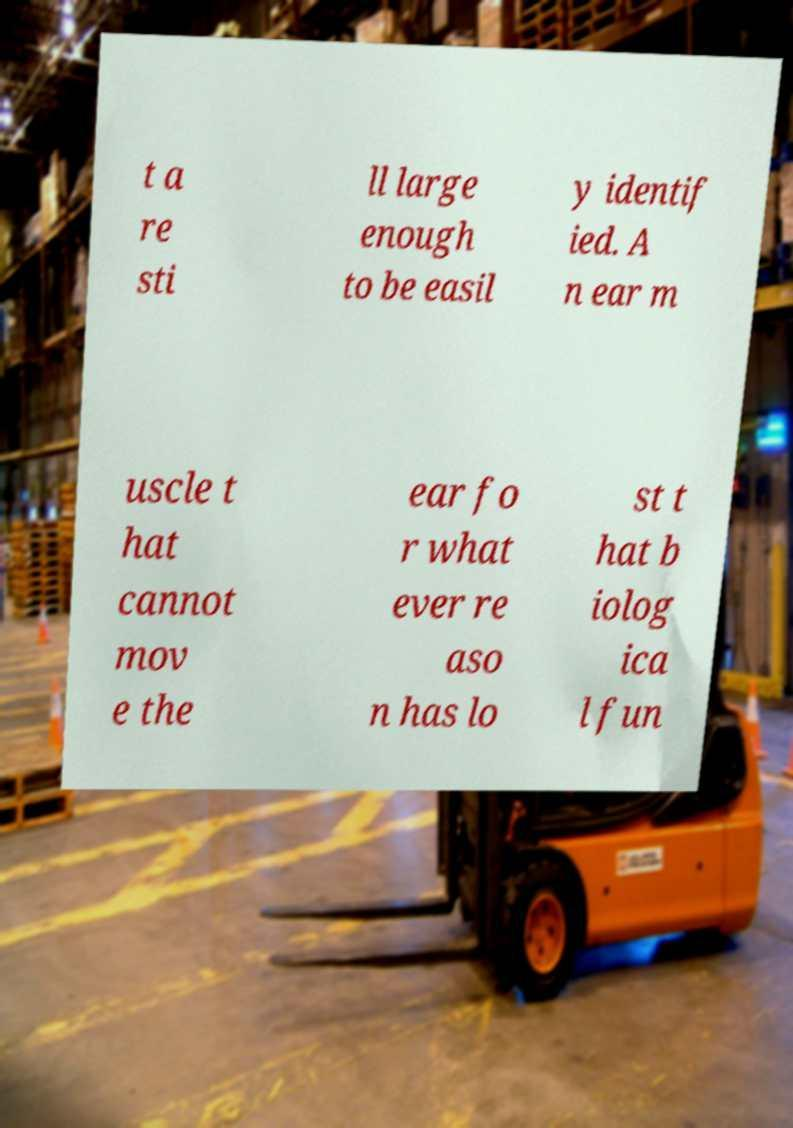Please read and relay the text visible in this image. What does it say? t a re sti ll large enough to be easil y identif ied. A n ear m uscle t hat cannot mov e the ear fo r what ever re aso n has lo st t hat b iolog ica l fun 